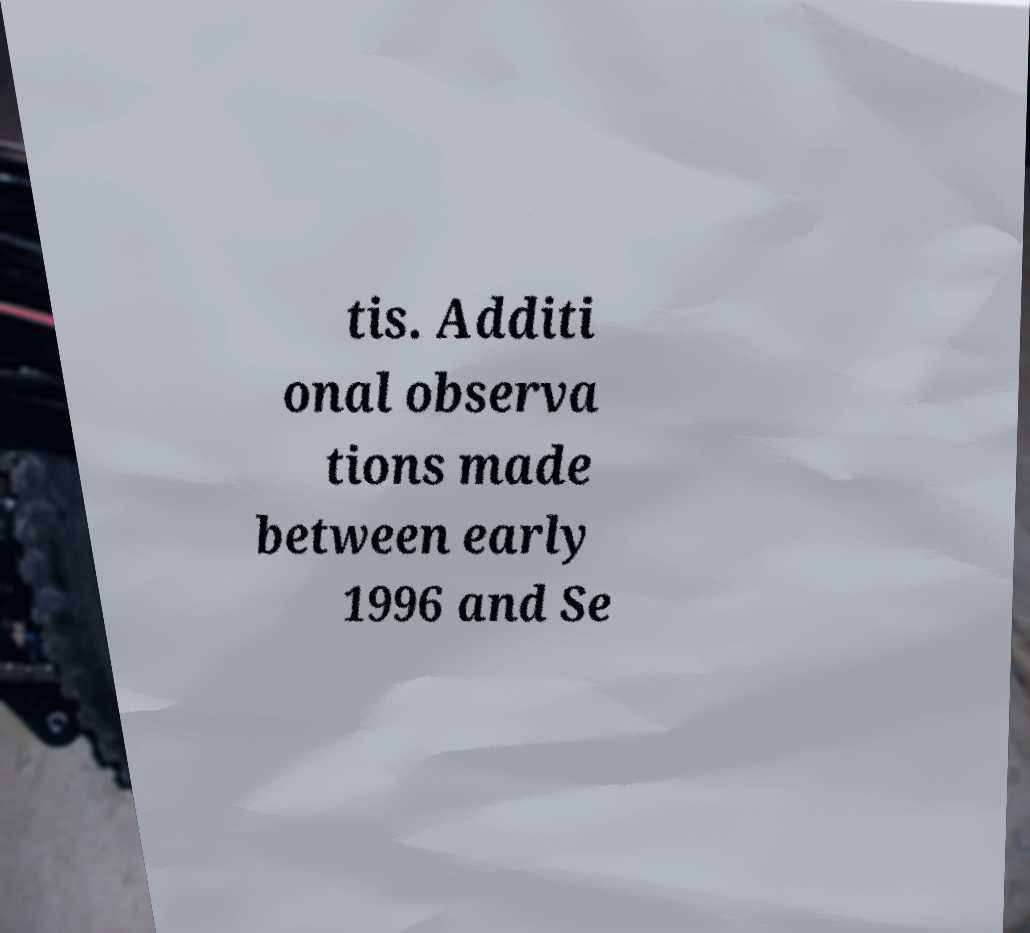Could you extract and type out the text from this image? tis. Additi onal observa tions made between early 1996 and Se 